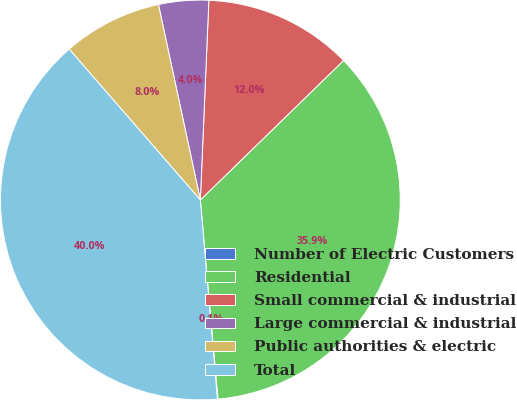Convert chart. <chart><loc_0><loc_0><loc_500><loc_500><pie_chart><fcel>Number of Electric Customers<fcel>Residential<fcel>Small commercial & industrial<fcel>Large commercial & industrial<fcel>Public authorities & electric<fcel>Total<nl><fcel>0.05%<fcel>35.88%<fcel>12.03%<fcel>4.04%<fcel>8.03%<fcel>39.97%<nl></chart> 